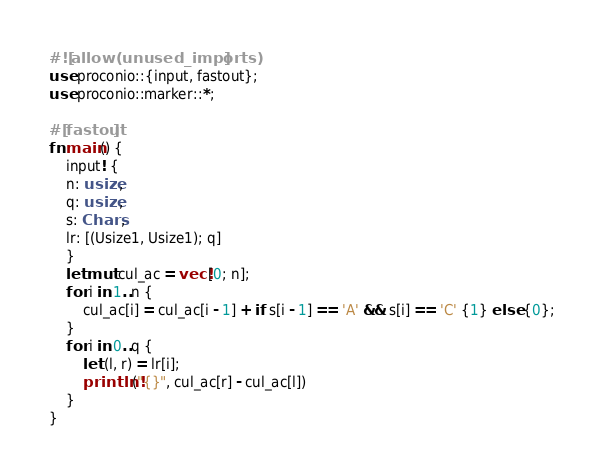<code> <loc_0><loc_0><loc_500><loc_500><_Rust_>#![allow(unused_imports)]
use proconio::{input, fastout};
use proconio::marker::*;

#[fastout]
fn main() {
    input! {
    n: usize,
    q: usize,
    s: Chars,
    lr: [(Usize1, Usize1); q]
    }
    let mut cul_ac = vec![0; n];
    for i in 1..n {
        cul_ac[i] = cul_ac[i - 1] + if s[i - 1] == 'A' && s[i] == 'C' {1} else {0};
    }
    for i in 0..q {
        let (l, r) = lr[i];
        println!("{}", cul_ac[r] - cul_ac[l])
    }
}
</code> 